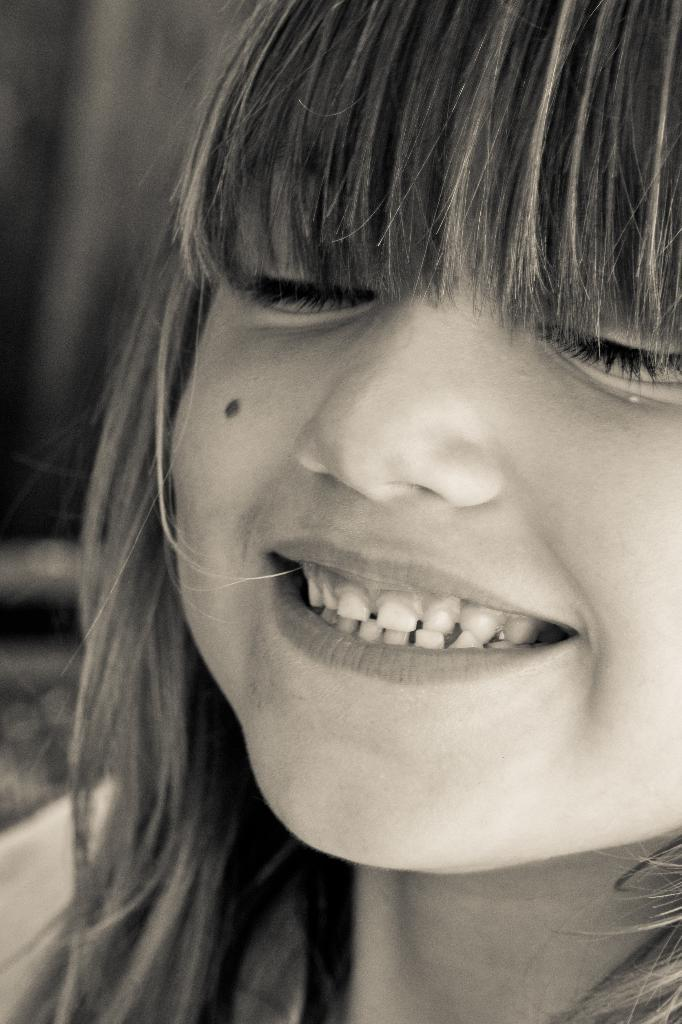What is the color scheme of the image? The image is black and white. What is the main subject of the image? There is a girl in the image. What is the girl doing in the image? The girl is smiling. What type of sack can be seen in the image? There is no sack present in the image. What kind of stone is visible in the image? There is no stone present in the image. 